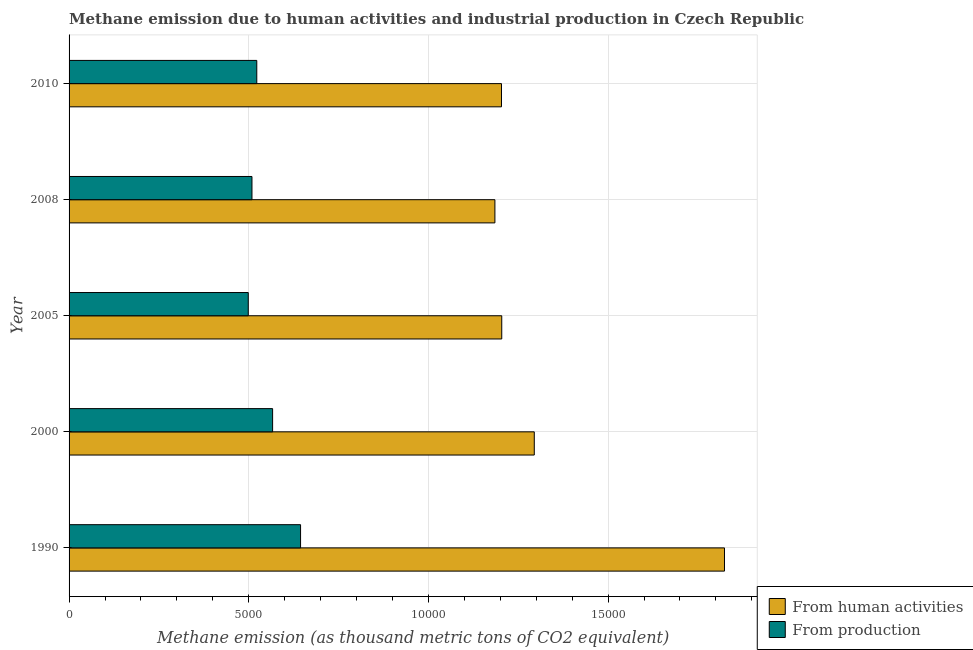How many different coloured bars are there?
Give a very brief answer. 2. How many groups of bars are there?
Keep it short and to the point. 5. Are the number of bars per tick equal to the number of legend labels?
Provide a short and direct response. Yes. What is the label of the 3rd group of bars from the top?
Your answer should be very brief. 2005. In how many cases, is the number of bars for a given year not equal to the number of legend labels?
Keep it short and to the point. 0. What is the amount of emissions generated from industries in 2008?
Your answer should be very brief. 5089.7. Across all years, what is the maximum amount of emissions generated from industries?
Provide a short and direct response. 6442.2. Across all years, what is the minimum amount of emissions generated from industries?
Your answer should be compact. 4986.9. In which year was the amount of emissions generated from industries maximum?
Your answer should be very brief. 1990. In which year was the amount of emissions from human activities minimum?
Keep it short and to the point. 2008. What is the total amount of emissions from human activities in the graph?
Your response must be concise. 6.71e+04. What is the difference between the amount of emissions generated from industries in 2005 and that in 2010?
Your answer should be compact. -236.9. What is the difference between the amount of emissions generated from industries in 2010 and the amount of emissions from human activities in 1990?
Offer a terse response. -1.30e+04. What is the average amount of emissions generated from industries per year?
Make the answer very short. 5481.36. In the year 2000, what is the difference between the amount of emissions from human activities and amount of emissions generated from industries?
Give a very brief answer. 7282. In how many years, is the amount of emissions generated from industries greater than 13000 thousand metric tons?
Offer a very short reply. 0. What is the difference between the highest and the second highest amount of emissions generated from industries?
Keep it short and to the point. 778. What is the difference between the highest and the lowest amount of emissions generated from industries?
Offer a terse response. 1455.3. In how many years, is the amount of emissions generated from industries greater than the average amount of emissions generated from industries taken over all years?
Your answer should be very brief. 2. What does the 1st bar from the top in 2008 represents?
Your response must be concise. From production. What does the 2nd bar from the bottom in 2010 represents?
Offer a terse response. From production. How many bars are there?
Ensure brevity in your answer.  10. Does the graph contain any zero values?
Provide a short and direct response. No. Does the graph contain grids?
Provide a succinct answer. Yes. How many legend labels are there?
Give a very brief answer. 2. How are the legend labels stacked?
Ensure brevity in your answer.  Vertical. What is the title of the graph?
Your answer should be very brief. Methane emission due to human activities and industrial production in Czech Republic. What is the label or title of the X-axis?
Your answer should be very brief. Methane emission (as thousand metric tons of CO2 equivalent). What is the Methane emission (as thousand metric tons of CO2 equivalent) in From human activities in 1990?
Provide a succinct answer. 1.82e+04. What is the Methane emission (as thousand metric tons of CO2 equivalent) of From production in 1990?
Give a very brief answer. 6442.2. What is the Methane emission (as thousand metric tons of CO2 equivalent) in From human activities in 2000?
Your answer should be very brief. 1.29e+04. What is the Methane emission (as thousand metric tons of CO2 equivalent) in From production in 2000?
Offer a terse response. 5664.2. What is the Methane emission (as thousand metric tons of CO2 equivalent) in From human activities in 2005?
Keep it short and to the point. 1.20e+04. What is the Methane emission (as thousand metric tons of CO2 equivalent) in From production in 2005?
Give a very brief answer. 4986.9. What is the Methane emission (as thousand metric tons of CO2 equivalent) in From human activities in 2008?
Provide a short and direct response. 1.19e+04. What is the Methane emission (as thousand metric tons of CO2 equivalent) of From production in 2008?
Keep it short and to the point. 5089.7. What is the Methane emission (as thousand metric tons of CO2 equivalent) of From human activities in 2010?
Give a very brief answer. 1.20e+04. What is the Methane emission (as thousand metric tons of CO2 equivalent) of From production in 2010?
Provide a short and direct response. 5223.8. Across all years, what is the maximum Methane emission (as thousand metric tons of CO2 equivalent) in From human activities?
Offer a terse response. 1.82e+04. Across all years, what is the maximum Methane emission (as thousand metric tons of CO2 equivalent) in From production?
Your response must be concise. 6442.2. Across all years, what is the minimum Methane emission (as thousand metric tons of CO2 equivalent) in From human activities?
Give a very brief answer. 1.19e+04. Across all years, what is the minimum Methane emission (as thousand metric tons of CO2 equivalent) in From production?
Keep it short and to the point. 4986.9. What is the total Methane emission (as thousand metric tons of CO2 equivalent) in From human activities in the graph?
Offer a very short reply. 6.71e+04. What is the total Methane emission (as thousand metric tons of CO2 equivalent) in From production in the graph?
Make the answer very short. 2.74e+04. What is the difference between the Methane emission (as thousand metric tons of CO2 equivalent) of From human activities in 1990 and that in 2000?
Offer a terse response. 5293.1. What is the difference between the Methane emission (as thousand metric tons of CO2 equivalent) in From production in 1990 and that in 2000?
Your answer should be very brief. 778. What is the difference between the Methane emission (as thousand metric tons of CO2 equivalent) of From human activities in 1990 and that in 2005?
Give a very brief answer. 6198.5. What is the difference between the Methane emission (as thousand metric tons of CO2 equivalent) of From production in 1990 and that in 2005?
Your response must be concise. 1455.3. What is the difference between the Methane emission (as thousand metric tons of CO2 equivalent) of From human activities in 1990 and that in 2008?
Your answer should be very brief. 6388.9. What is the difference between the Methane emission (as thousand metric tons of CO2 equivalent) in From production in 1990 and that in 2008?
Your answer should be very brief. 1352.5. What is the difference between the Methane emission (as thousand metric tons of CO2 equivalent) in From human activities in 1990 and that in 2010?
Your answer should be very brief. 6205.9. What is the difference between the Methane emission (as thousand metric tons of CO2 equivalent) of From production in 1990 and that in 2010?
Provide a succinct answer. 1218.4. What is the difference between the Methane emission (as thousand metric tons of CO2 equivalent) in From human activities in 2000 and that in 2005?
Make the answer very short. 905.4. What is the difference between the Methane emission (as thousand metric tons of CO2 equivalent) of From production in 2000 and that in 2005?
Make the answer very short. 677.3. What is the difference between the Methane emission (as thousand metric tons of CO2 equivalent) of From human activities in 2000 and that in 2008?
Ensure brevity in your answer.  1095.8. What is the difference between the Methane emission (as thousand metric tons of CO2 equivalent) in From production in 2000 and that in 2008?
Your answer should be compact. 574.5. What is the difference between the Methane emission (as thousand metric tons of CO2 equivalent) of From human activities in 2000 and that in 2010?
Keep it short and to the point. 912.8. What is the difference between the Methane emission (as thousand metric tons of CO2 equivalent) in From production in 2000 and that in 2010?
Make the answer very short. 440.4. What is the difference between the Methane emission (as thousand metric tons of CO2 equivalent) of From human activities in 2005 and that in 2008?
Make the answer very short. 190.4. What is the difference between the Methane emission (as thousand metric tons of CO2 equivalent) of From production in 2005 and that in 2008?
Keep it short and to the point. -102.8. What is the difference between the Methane emission (as thousand metric tons of CO2 equivalent) of From human activities in 2005 and that in 2010?
Your response must be concise. 7.4. What is the difference between the Methane emission (as thousand metric tons of CO2 equivalent) in From production in 2005 and that in 2010?
Ensure brevity in your answer.  -236.9. What is the difference between the Methane emission (as thousand metric tons of CO2 equivalent) in From human activities in 2008 and that in 2010?
Provide a succinct answer. -183. What is the difference between the Methane emission (as thousand metric tons of CO2 equivalent) in From production in 2008 and that in 2010?
Your response must be concise. -134.1. What is the difference between the Methane emission (as thousand metric tons of CO2 equivalent) in From human activities in 1990 and the Methane emission (as thousand metric tons of CO2 equivalent) in From production in 2000?
Provide a short and direct response. 1.26e+04. What is the difference between the Methane emission (as thousand metric tons of CO2 equivalent) in From human activities in 1990 and the Methane emission (as thousand metric tons of CO2 equivalent) in From production in 2005?
Ensure brevity in your answer.  1.33e+04. What is the difference between the Methane emission (as thousand metric tons of CO2 equivalent) in From human activities in 1990 and the Methane emission (as thousand metric tons of CO2 equivalent) in From production in 2008?
Offer a very short reply. 1.31e+04. What is the difference between the Methane emission (as thousand metric tons of CO2 equivalent) in From human activities in 1990 and the Methane emission (as thousand metric tons of CO2 equivalent) in From production in 2010?
Offer a very short reply. 1.30e+04. What is the difference between the Methane emission (as thousand metric tons of CO2 equivalent) in From human activities in 2000 and the Methane emission (as thousand metric tons of CO2 equivalent) in From production in 2005?
Make the answer very short. 7959.3. What is the difference between the Methane emission (as thousand metric tons of CO2 equivalent) in From human activities in 2000 and the Methane emission (as thousand metric tons of CO2 equivalent) in From production in 2008?
Your response must be concise. 7856.5. What is the difference between the Methane emission (as thousand metric tons of CO2 equivalent) in From human activities in 2000 and the Methane emission (as thousand metric tons of CO2 equivalent) in From production in 2010?
Offer a very short reply. 7722.4. What is the difference between the Methane emission (as thousand metric tons of CO2 equivalent) of From human activities in 2005 and the Methane emission (as thousand metric tons of CO2 equivalent) of From production in 2008?
Provide a succinct answer. 6951.1. What is the difference between the Methane emission (as thousand metric tons of CO2 equivalent) in From human activities in 2005 and the Methane emission (as thousand metric tons of CO2 equivalent) in From production in 2010?
Make the answer very short. 6817. What is the difference between the Methane emission (as thousand metric tons of CO2 equivalent) in From human activities in 2008 and the Methane emission (as thousand metric tons of CO2 equivalent) in From production in 2010?
Your answer should be very brief. 6626.6. What is the average Methane emission (as thousand metric tons of CO2 equivalent) in From human activities per year?
Your response must be concise. 1.34e+04. What is the average Methane emission (as thousand metric tons of CO2 equivalent) in From production per year?
Your answer should be very brief. 5481.36. In the year 1990, what is the difference between the Methane emission (as thousand metric tons of CO2 equivalent) of From human activities and Methane emission (as thousand metric tons of CO2 equivalent) of From production?
Make the answer very short. 1.18e+04. In the year 2000, what is the difference between the Methane emission (as thousand metric tons of CO2 equivalent) in From human activities and Methane emission (as thousand metric tons of CO2 equivalent) in From production?
Ensure brevity in your answer.  7282. In the year 2005, what is the difference between the Methane emission (as thousand metric tons of CO2 equivalent) of From human activities and Methane emission (as thousand metric tons of CO2 equivalent) of From production?
Provide a short and direct response. 7053.9. In the year 2008, what is the difference between the Methane emission (as thousand metric tons of CO2 equivalent) in From human activities and Methane emission (as thousand metric tons of CO2 equivalent) in From production?
Make the answer very short. 6760.7. In the year 2010, what is the difference between the Methane emission (as thousand metric tons of CO2 equivalent) in From human activities and Methane emission (as thousand metric tons of CO2 equivalent) in From production?
Provide a short and direct response. 6809.6. What is the ratio of the Methane emission (as thousand metric tons of CO2 equivalent) in From human activities in 1990 to that in 2000?
Provide a succinct answer. 1.41. What is the ratio of the Methane emission (as thousand metric tons of CO2 equivalent) of From production in 1990 to that in 2000?
Ensure brevity in your answer.  1.14. What is the ratio of the Methane emission (as thousand metric tons of CO2 equivalent) of From human activities in 1990 to that in 2005?
Your answer should be very brief. 1.51. What is the ratio of the Methane emission (as thousand metric tons of CO2 equivalent) of From production in 1990 to that in 2005?
Your answer should be very brief. 1.29. What is the ratio of the Methane emission (as thousand metric tons of CO2 equivalent) of From human activities in 1990 to that in 2008?
Provide a succinct answer. 1.54. What is the ratio of the Methane emission (as thousand metric tons of CO2 equivalent) in From production in 1990 to that in 2008?
Make the answer very short. 1.27. What is the ratio of the Methane emission (as thousand metric tons of CO2 equivalent) in From human activities in 1990 to that in 2010?
Provide a succinct answer. 1.52. What is the ratio of the Methane emission (as thousand metric tons of CO2 equivalent) of From production in 1990 to that in 2010?
Offer a very short reply. 1.23. What is the ratio of the Methane emission (as thousand metric tons of CO2 equivalent) of From human activities in 2000 to that in 2005?
Give a very brief answer. 1.08. What is the ratio of the Methane emission (as thousand metric tons of CO2 equivalent) in From production in 2000 to that in 2005?
Offer a very short reply. 1.14. What is the ratio of the Methane emission (as thousand metric tons of CO2 equivalent) in From human activities in 2000 to that in 2008?
Give a very brief answer. 1.09. What is the ratio of the Methane emission (as thousand metric tons of CO2 equivalent) of From production in 2000 to that in 2008?
Make the answer very short. 1.11. What is the ratio of the Methane emission (as thousand metric tons of CO2 equivalent) of From human activities in 2000 to that in 2010?
Keep it short and to the point. 1.08. What is the ratio of the Methane emission (as thousand metric tons of CO2 equivalent) of From production in 2000 to that in 2010?
Offer a terse response. 1.08. What is the ratio of the Methane emission (as thousand metric tons of CO2 equivalent) of From human activities in 2005 to that in 2008?
Give a very brief answer. 1.02. What is the ratio of the Methane emission (as thousand metric tons of CO2 equivalent) in From production in 2005 to that in 2008?
Provide a short and direct response. 0.98. What is the ratio of the Methane emission (as thousand metric tons of CO2 equivalent) of From production in 2005 to that in 2010?
Make the answer very short. 0.95. What is the ratio of the Methane emission (as thousand metric tons of CO2 equivalent) in From production in 2008 to that in 2010?
Your answer should be very brief. 0.97. What is the difference between the highest and the second highest Methane emission (as thousand metric tons of CO2 equivalent) in From human activities?
Your answer should be very brief. 5293.1. What is the difference between the highest and the second highest Methane emission (as thousand metric tons of CO2 equivalent) of From production?
Your answer should be compact. 778. What is the difference between the highest and the lowest Methane emission (as thousand metric tons of CO2 equivalent) in From human activities?
Offer a very short reply. 6388.9. What is the difference between the highest and the lowest Methane emission (as thousand metric tons of CO2 equivalent) in From production?
Your answer should be very brief. 1455.3. 